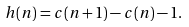<formula> <loc_0><loc_0><loc_500><loc_500>h ( n ) = c ( n + 1 ) - c ( n ) - 1 .</formula> 